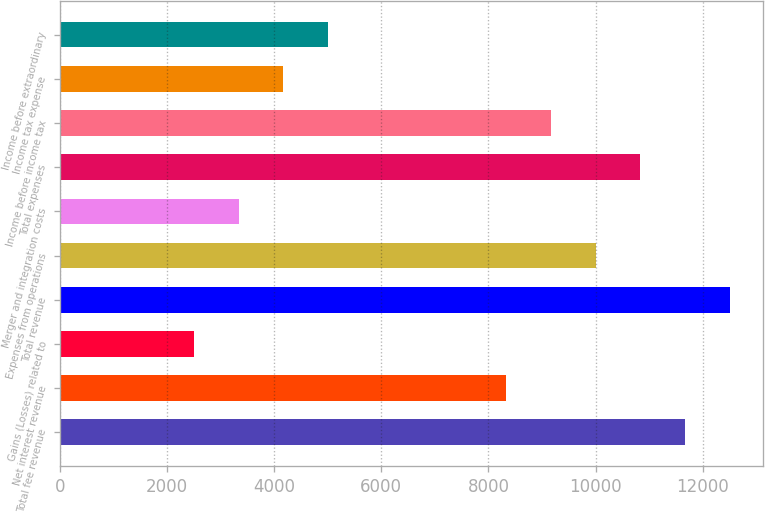Convert chart. <chart><loc_0><loc_0><loc_500><loc_500><bar_chart><fcel>Total fee revenue<fcel>Net interest revenue<fcel>Gains (Losses) related to<fcel>Total revenue<fcel>Expenses from operations<fcel>Merger and integration costs<fcel>Total expenses<fcel>Income before income tax<fcel>Income tax expense<fcel>Income before extraordinary<nl><fcel>11669<fcel>8335.98<fcel>2503.22<fcel>12502.2<fcel>10002.5<fcel>3336.47<fcel>10835.7<fcel>9169.23<fcel>4169.72<fcel>5002.98<nl></chart> 